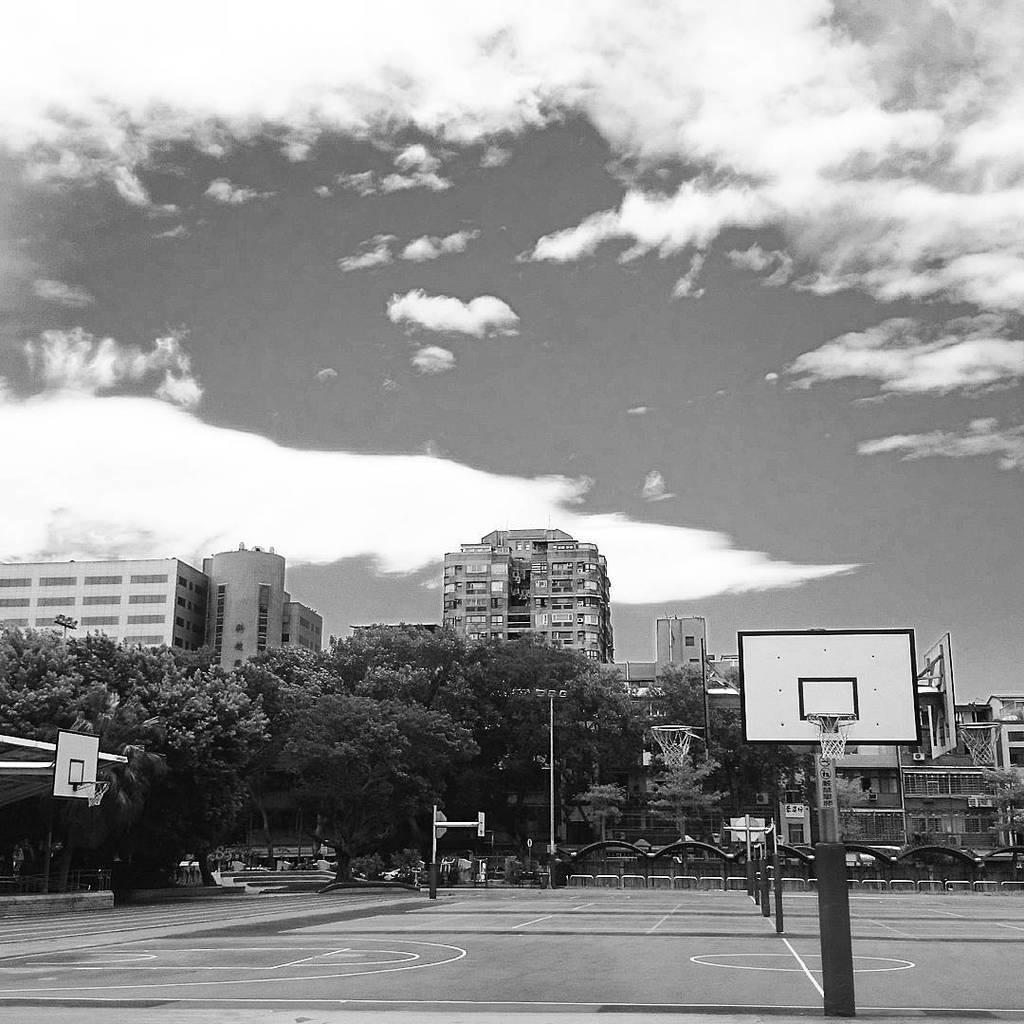Can you describe this image briefly? This is a black and white picture. In the background we can see the clouds in the sky, buildings, trees. In this picture we can see the railing, basketball court, lights, pole and the basketball hoops. 